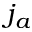Convert formula to latex. <formula><loc_0><loc_0><loc_500><loc_500>j _ { a }</formula> 